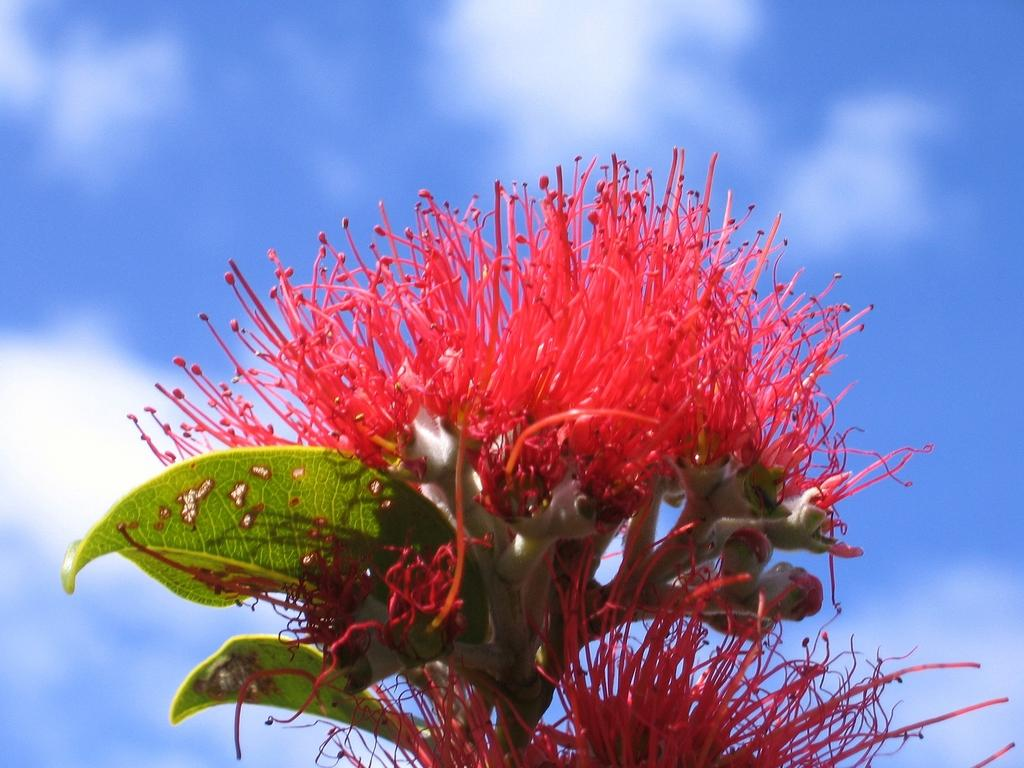What type of plant is featured in the image? There is a flower in the image, which is a type of plant. What else can be seen in the image besides the flower? There is a plant in the image. What is visible in the background of the image? The background of the image includes the sky. What can be observed in the sky in the image? Clouds are visible in the sky. Where is the lunchroom located in the image? There is no lunchroom present in the image; it features a flower, a plant, and a sky background with clouds. What is the texture of the airplane in the image? There is no airplane present in the image, so its texture cannot be determined. 